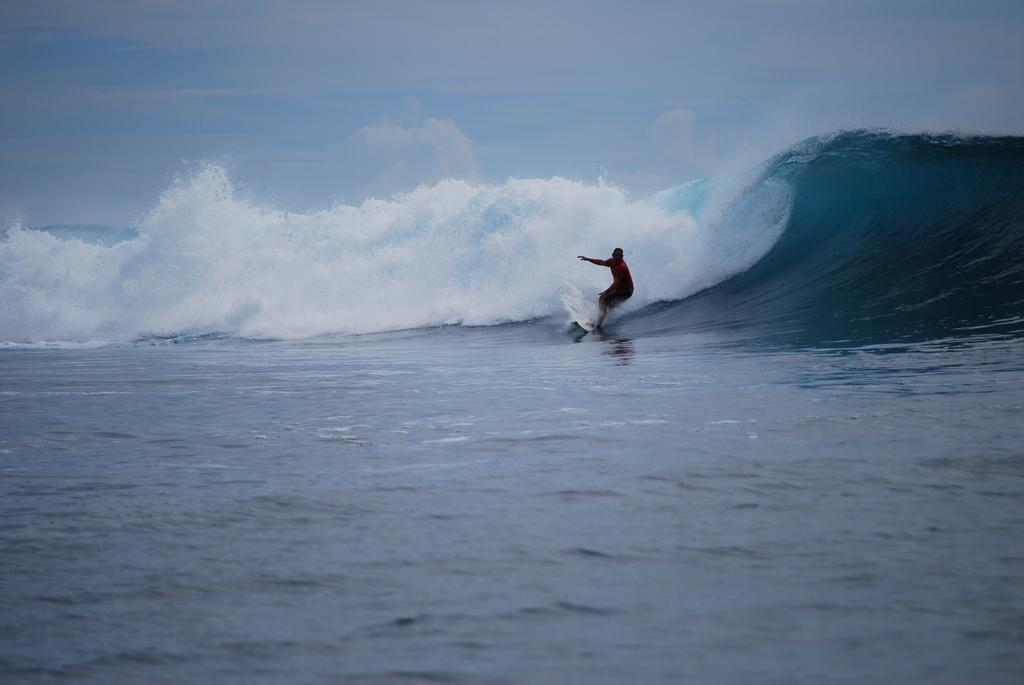What is the main subject of the image? There is a person in the image. What is the person doing in the image? The person is surfing on water. What can be seen in the background of the image? The sky is visible in the background of the image. What type of religious ceremony is taking place in the image? There is no indication of a religious ceremony in the image; it features a person surfing on water. Can you describe the zephyr's effect on the person's surfing in the image? A: There is no mention of a zephyr or any wind in the image; it simply shows a person surfing on water. 